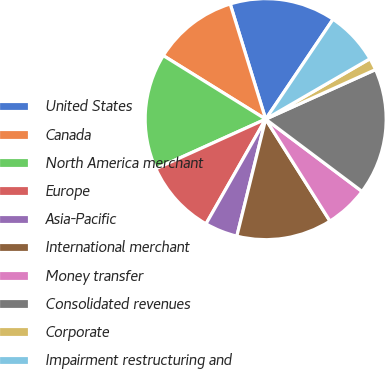Convert chart. <chart><loc_0><loc_0><loc_500><loc_500><pie_chart><fcel>United States<fcel>Canada<fcel>North America merchant<fcel>Europe<fcel>Asia-Pacific<fcel>International merchant<fcel>Money transfer<fcel>Consolidated revenues<fcel>Corporate<fcel>Impairment restructuring and<nl><fcel>14.2%<fcel>11.4%<fcel>15.6%<fcel>10.0%<fcel>4.4%<fcel>12.8%<fcel>5.8%<fcel>16.99%<fcel>1.61%<fcel>7.2%<nl></chart> 